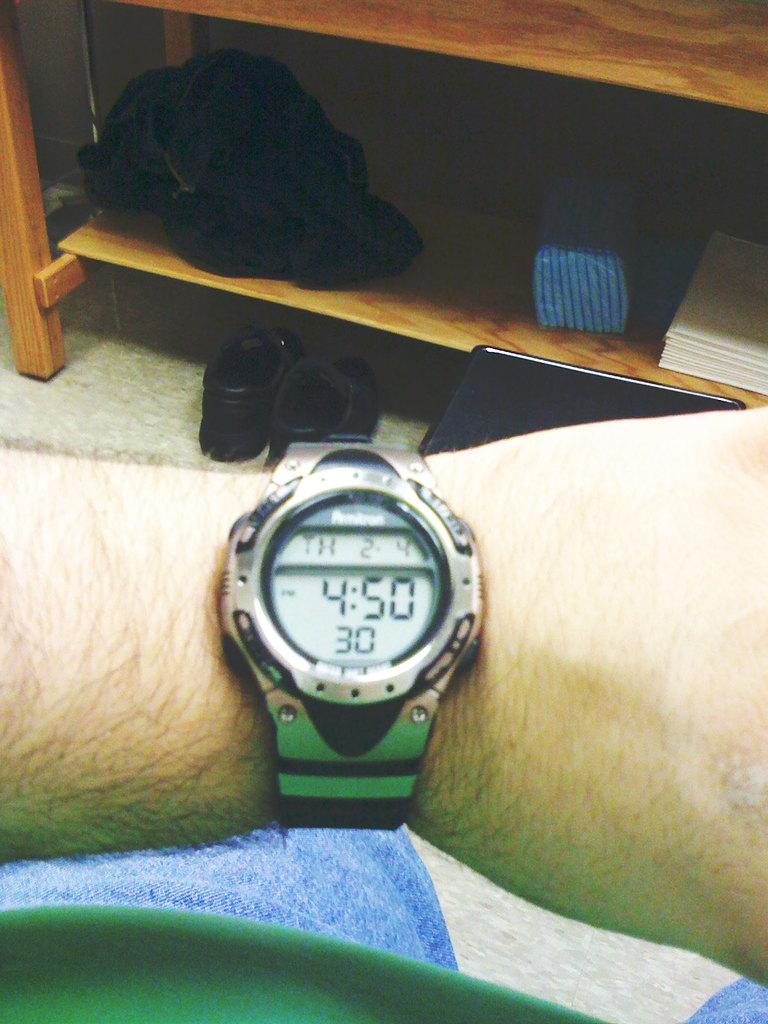<image>
Render a clear and concise summary of the photo. A watch on someone's wrist that shows a time of 4:50, with the rest of the room in the background. 